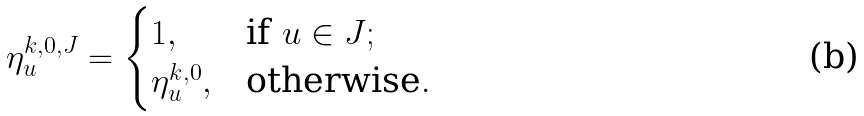<formula> <loc_0><loc_0><loc_500><loc_500>\eta ^ { k , 0 , J } _ { u } = \begin{cases} 1 , & \text {if } u \in J ; \\ \eta ^ { k , 0 } _ { u } , & \text {otherwise} . \end{cases}</formula> 